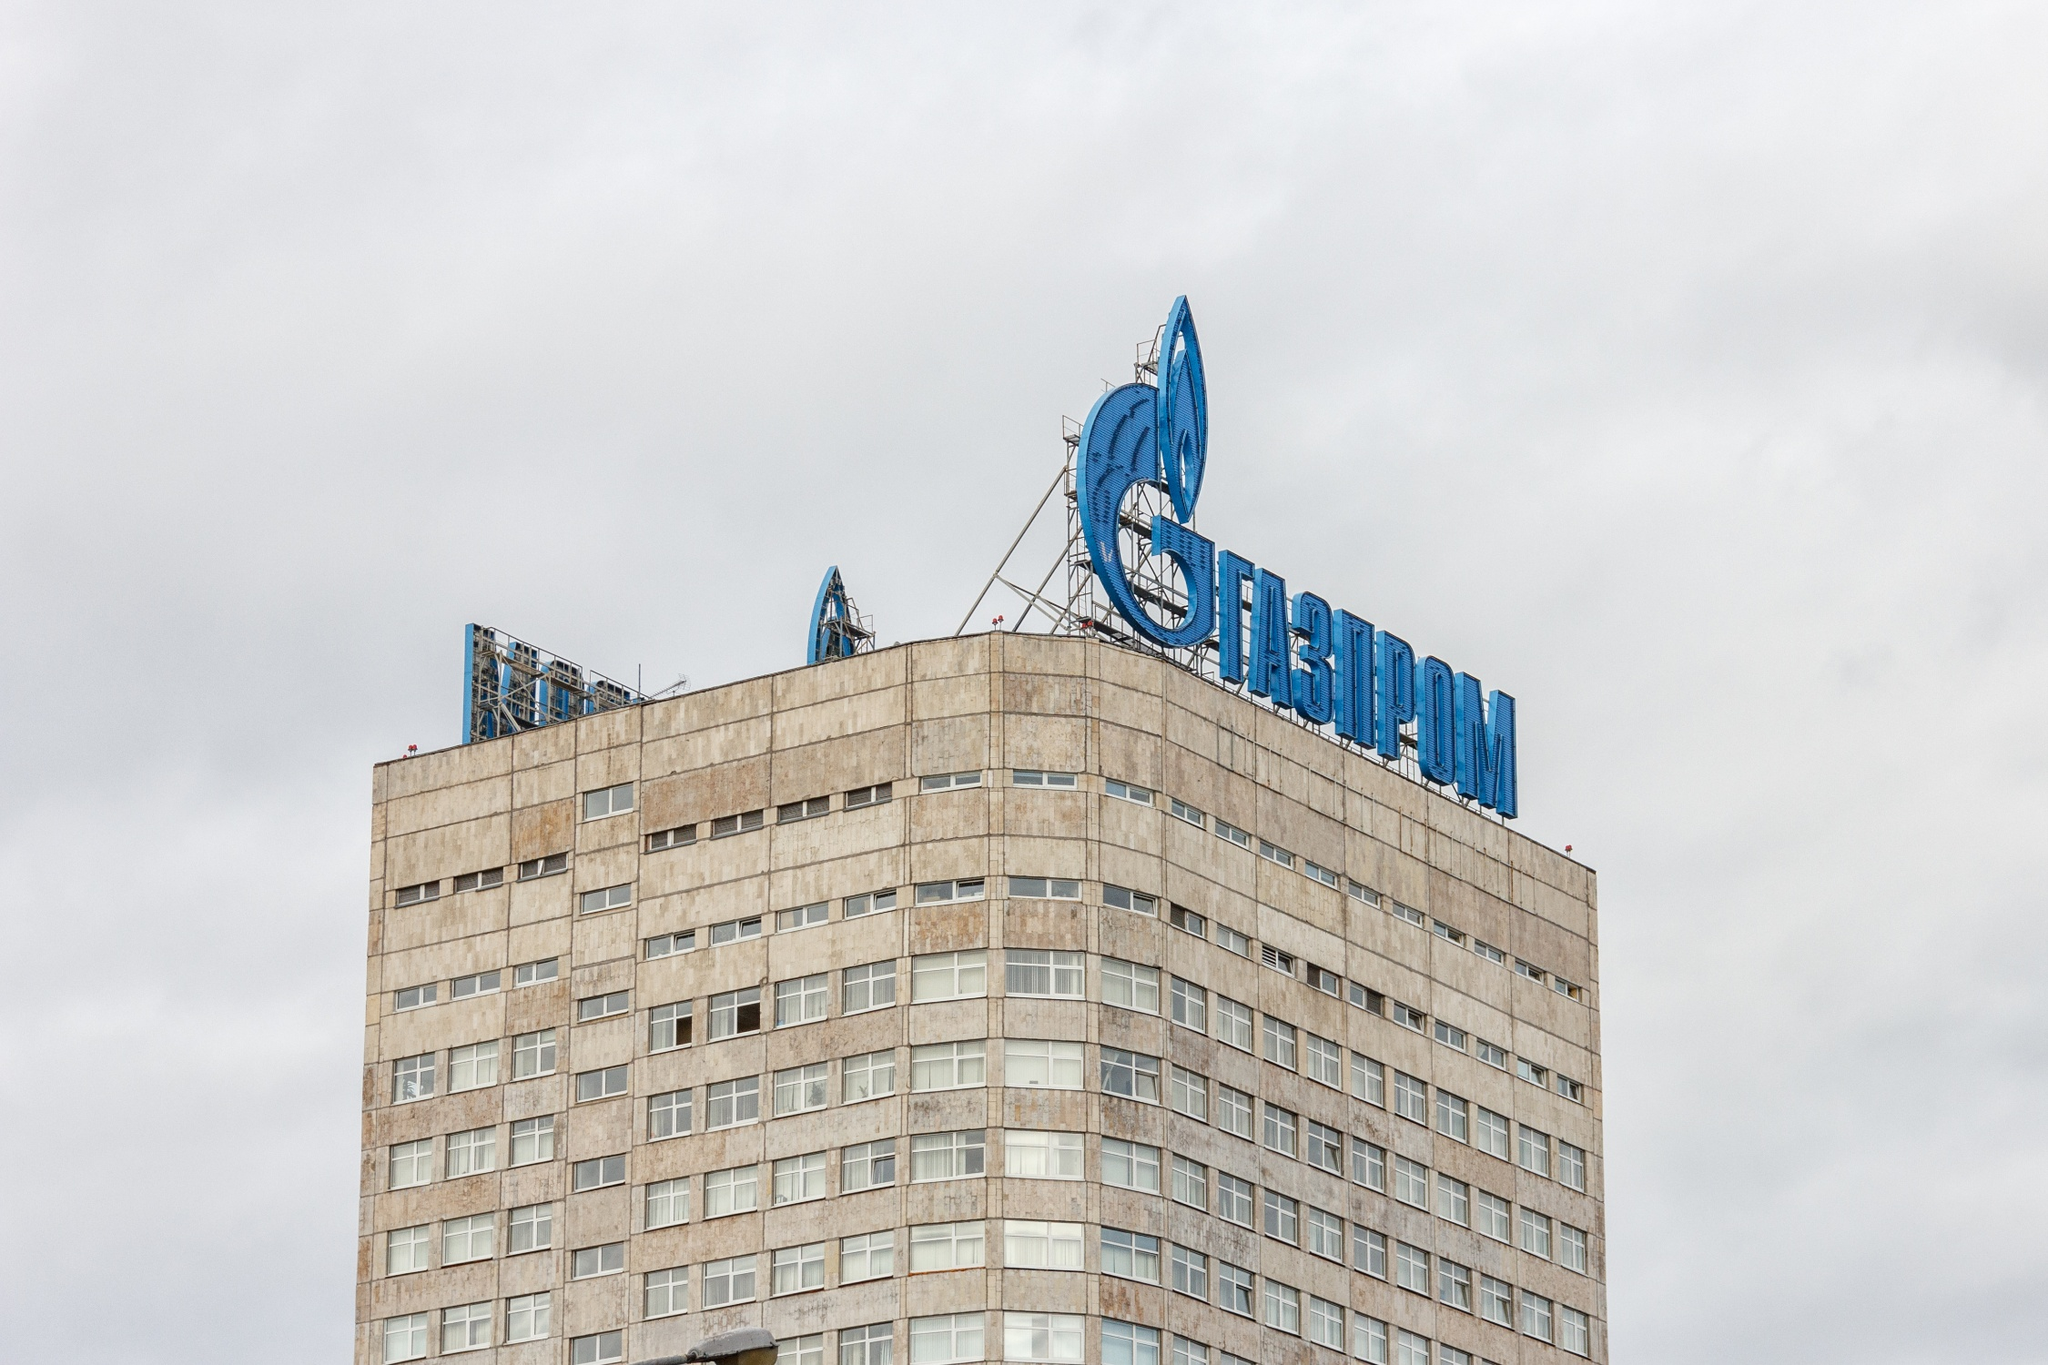What story do you think this building tells about the city it is in? The Gazprom headquarters in Moscow narrates a tale of modern Russia's economic and industrial prowess. The architectural elegance and towering structure of the building showcase the country's dedication to progress and innovation. The blue flame logo signifies Gazprom's dominance in the energy sector, underlining Moscow's significance as a hub of economic activity. The gray, overcast sky adds a tone of resilience, reflecting the city's historical endurance and adaptability amidst changing times. What do the materials and colors of the building convey? The materials and colors of the Gazprom headquarters convey a sense of modernity and stability. The neutral, light-toned materials used in the façade reflect a sleek and contemporary architectural style, which is effective in a corporate context. The blue color of the Gazprom logo stands out prominently, symbolizing energy, trust, and reliability. This combination of materials and colors underscores the company's role as a cornerstone in the energy sector and portrays a professional, robust corporate image. What's an imaginative, poetic interpretation of this image? Rising like a sentinel under a blanket of clouds, the Gazprom building pierces the sky with steadfast resolve. Its gray façade harmonizes with the heavens above, casting a stoic presence over the bustling city of Moscow. The blue flame at its apex isn't just a logo, but a beacon of industry and ambition, burning bright against the monochrome, as if whispering tales of ancient fires that powered empires of old. This modern monolith stands as an ode to human ingenuity, a stone sentinel watching over dreams that reach for the clouds. As a real-world scenario, what might be some daily operations happening inside this building? Inside the Gazprom headquarters, daily operations revolve around managing the complex and expansive activities of one of the world's largest energy companies. This includes strategic meetings to discuss pipeline projects, international negotiations with global partners, and research and development for new energy technologies. Teams work on financial planning, analyzing market trends, and ensuring compliance with regulatory standards. Amidst this bustling environment, employees move between floors, engaging in collaborative projects that contribute to Gazprom’s extensive energy network. Can you detail a specific scenario inside the Gazprom headquarters that might occur on an average working day? On an average working day inside the Gazprom headquarters, imagine a scenario in the boardroom on the top floor, where executives gather for a crucial meeting. The room is filled with the sound of hushed discussions, as projections are cast onto a large screen at the end, detailing the latest figures and forecasts for the upcoming quarter. A team from the financial department presents a detailed report on budget allocations for new exploration projects in Siberia, while legal advisors update the board on changes in international energy regulations. Simultaneously, in the lower floors, engineers and scientists work in state-of-the-art labs, testing innovative drilling techniques that could revolutionize the industry. The canteen buzzes with activity as employees take a break, exchanging ideas and news. This melting pot of strategies and innovations forms the lifeblood of Gazprom, driving the company forward in the global energy market. 